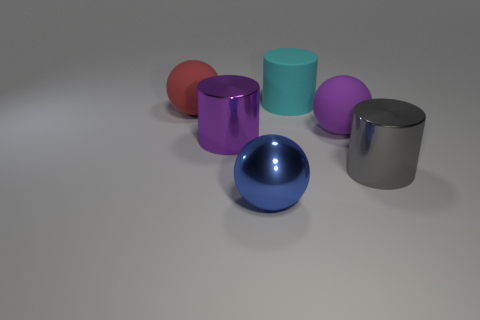Add 1 large metallic cylinders. How many objects exist? 7 Subtract 1 gray cylinders. How many objects are left? 5 Subtract all gray metal things. Subtract all big matte spheres. How many objects are left? 3 Add 3 big purple metal things. How many big purple metal things are left? 4 Add 6 big purple matte things. How many big purple matte things exist? 7 